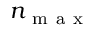Convert formula to latex. <formula><loc_0><loc_0><loc_500><loc_500>n _ { m a x }</formula> 